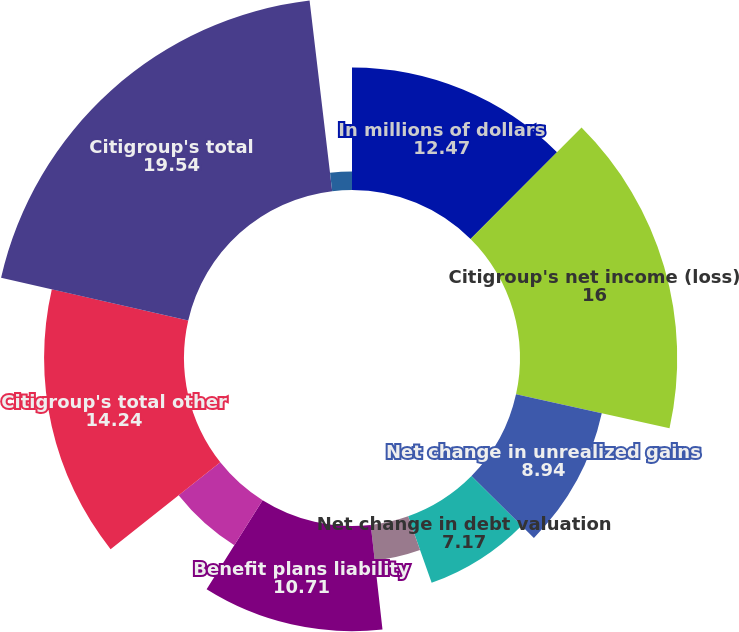Convert chart. <chart><loc_0><loc_0><loc_500><loc_500><pie_chart><fcel>In millions of dollars<fcel>Citigroup's net income (loss)<fcel>Net change in unrealized gains<fcel>Net change in debt valuation<fcel>Net change in cash flow hedges<fcel>Benefit plans liability<fcel>Net change in foreign currency<fcel>Citigroup's total other<fcel>Citigroup's total<fcel>Add Other comprehensive income<nl><fcel>12.47%<fcel>16.0%<fcel>8.94%<fcel>7.17%<fcel>3.64%<fcel>10.71%<fcel>5.41%<fcel>14.24%<fcel>19.54%<fcel>1.88%<nl></chart> 